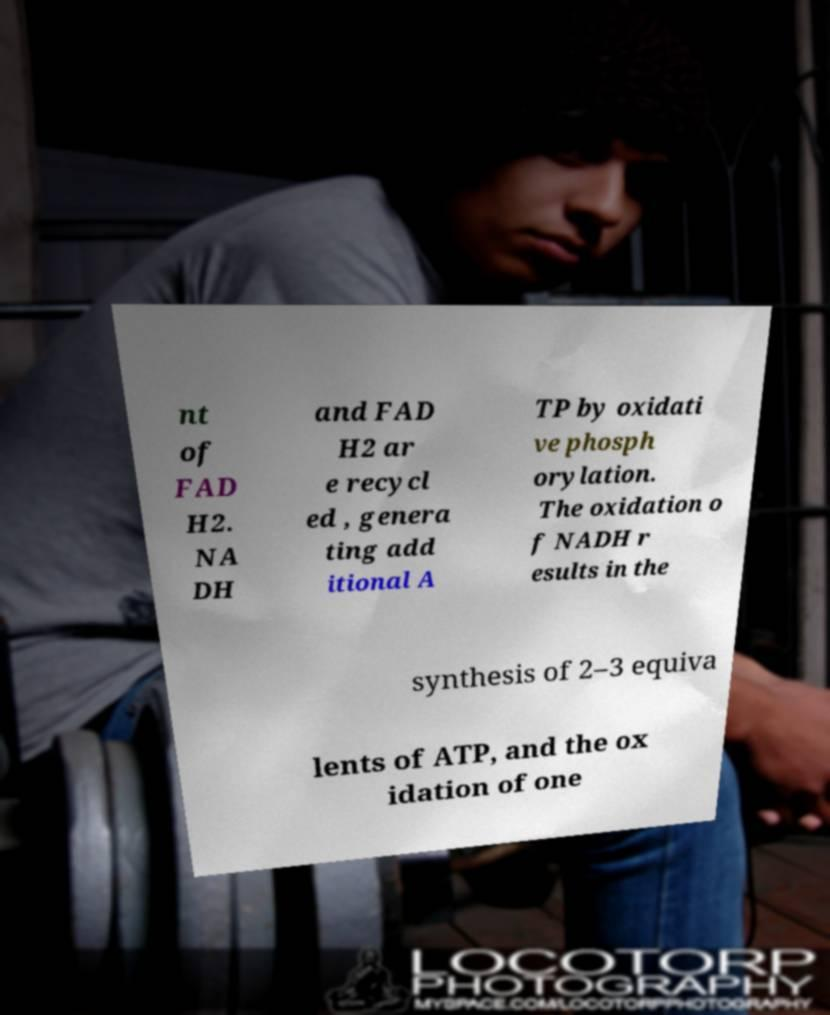Please read and relay the text visible in this image. What does it say? nt of FAD H2. NA DH and FAD H2 ar e recycl ed , genera ting add itional A TP by oxidati ve phosph orylation. The oxidation o f NADH r esults in the synthesis of 2–3 equiva lents of ATP, and the ox idation of one 